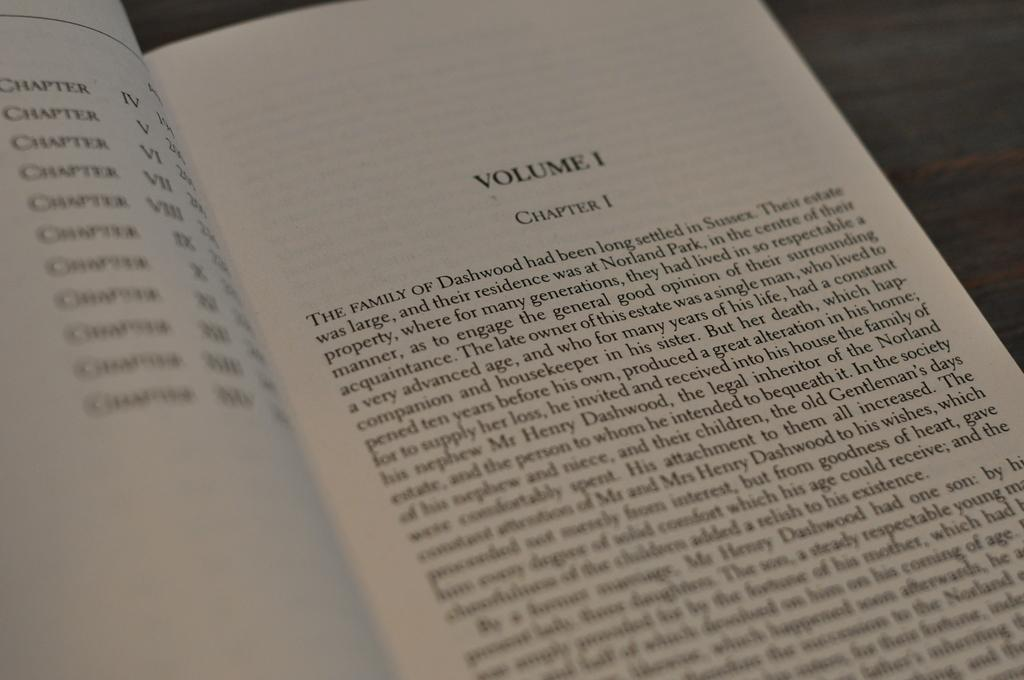<image>
Give a short and clear explanation of the subsequent image. A book is opened to a page labeled chapter one. 